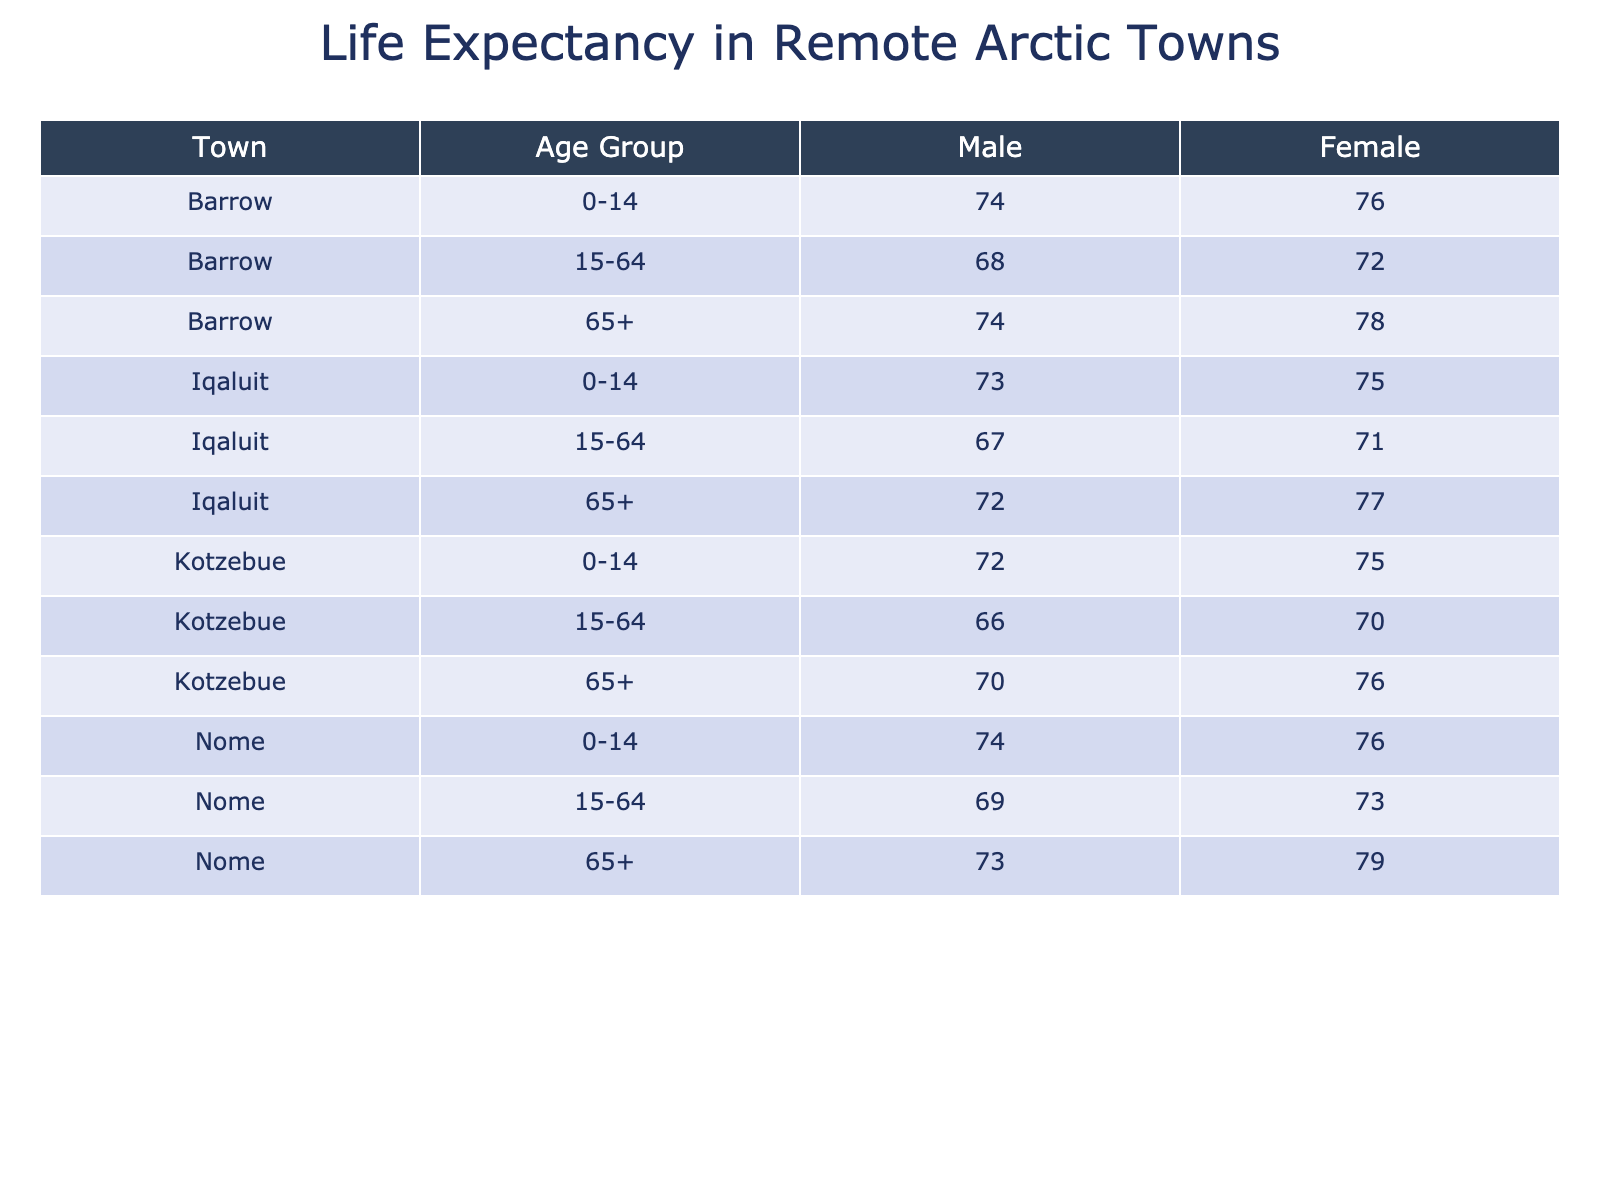What is the life expectancy for males aged 15-64 in Barrow? According to the table, the life expectancy for males in Barrow aged 15-64 is listed as 68 years.
Answer: 68 What is the life expectancy for females aged 65 and older in Iqaluit? The table shows that the life expectancy for females aged 65 and older in Iqaluit is 77 years.
Answer: 77 How does the life expectancy for females aged 0-14 compare between Kotzebue and Nome? From the table, in Kotzebue, females aged 0-14 have a life expectancy of 75 years, while in Nome, it is 76 years. This indicates that Nome has a higher life expectancy for this age group by 1 year.
Answer: Nome is higher by 1 year What is the overall average life expectancy for all the male age groups across the towns? To find the average life expectancy for males, we sum the life expectancies: (74 + 68 + 72 + 74 + 73 + 69 + 66 + 70 + 73) = 83. The number of entries is 9, so the average is 83/9 ≈ 73.33.
Answer: Approximately 73.33 Is it true that the life expectancy for females aged 15-64 in Nome is higher than that in Iqaluit? In Nome, the life expectancy for females aged 15-64 is 73 years while in Iqaluit it is 71 years. Therefore, it is true that Nome has a higher life expectancy for this age group.
Answer: Yes Which town has the highest life expectancy for males aged 0-14? The table shows that Barrow has the highest life expectancy for males aged 0-14 at 74 years, compared to both Iqaluit (73 years) and Kotzebue (72 years).
Answer: Barrow What is the difference in life expectancy for females aged 65 and older between Nome and Kotzebue? The life expectancy for females aged 65 and older in Nome is 79 years, while in Kotzebue it is 76 years. The difference is calculated as 79 - 76 = 3 years.
Answer: 3 years Which gender and age group combination has the lowest life expectancy in the towns listed? The table indicates that the lowest life expectancy is for males aged 15-64 in Kotzebue, which is 66 years.
Answer: Males aged 15-64 in Kotzebue What is the life expectancy trend for males as they age from 0-14 to 15-64 in Barrow? Examining Barrow's entries, males' life expectancy decreases from 74 years (0-14) to 68 years (15-64), illustrating a downward trend as age increases within this age range.
Answer: Decreasing trend 